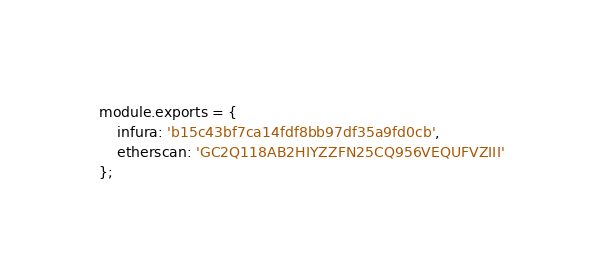Convert code to text. <code><loc_0><loc_0><loc_500><loc_500><_JavaScript_>module.exports = {
    infura: 'b15c43bf7ca14fdf8bb97df35a9fd0cb',
    etherscan: 'GC2Q118AB2HIYZZFN25CQ956VEQUFVZIII'
}; </code> 